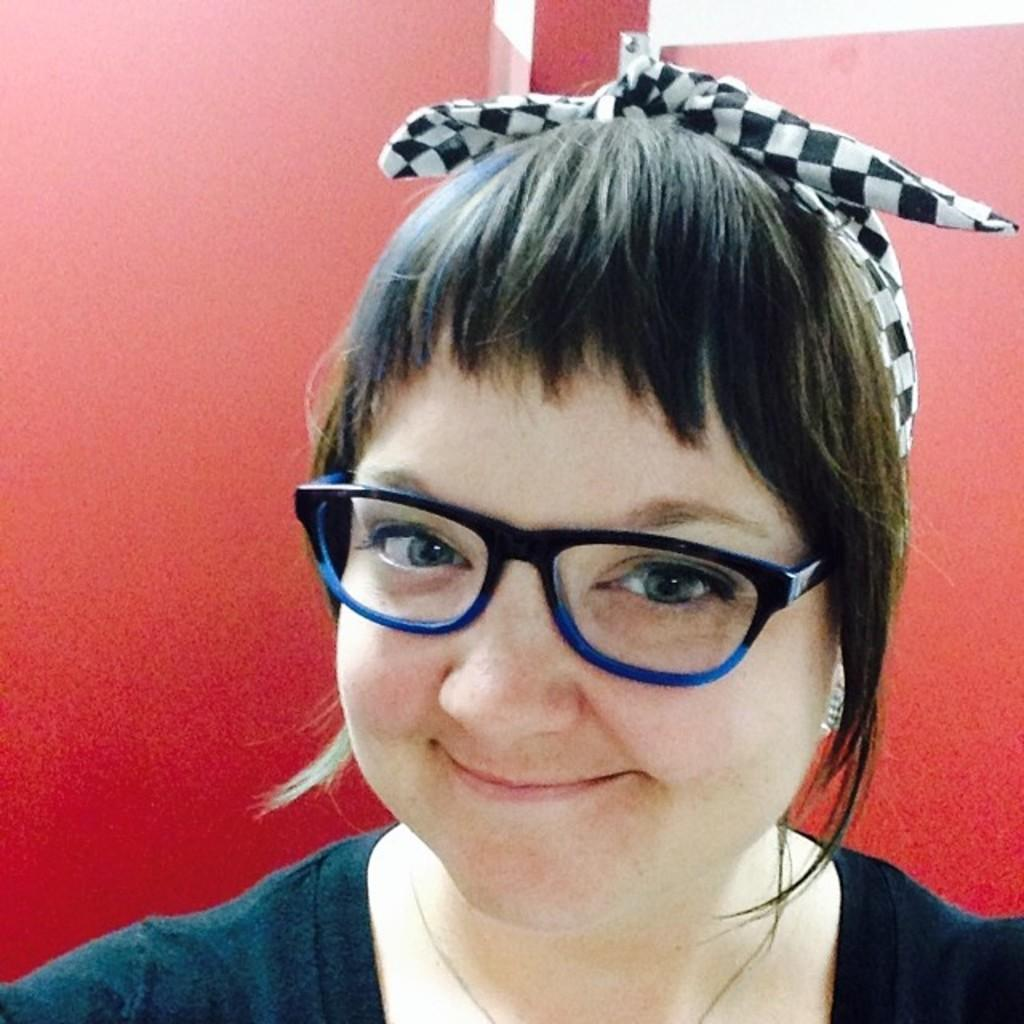Who is the main subject in the foreground of the image? There is a woman in the foreground of the image. What color is the background of the image? The background of the image is red in color. What type of religious ceremony is taking place in the background of the image? There is no indication of a religious ceremony or any religious elements in the image; the background is simply red in color. 